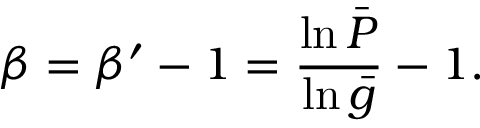Convert formula to latex. <formula><loc_0><loc_0><loc_500><loc_500>\beta = \beta ^ { \prime } - 1 = \frac { \ln \bar { P } } { \ln \bar { g } } - 1 .</formula> 